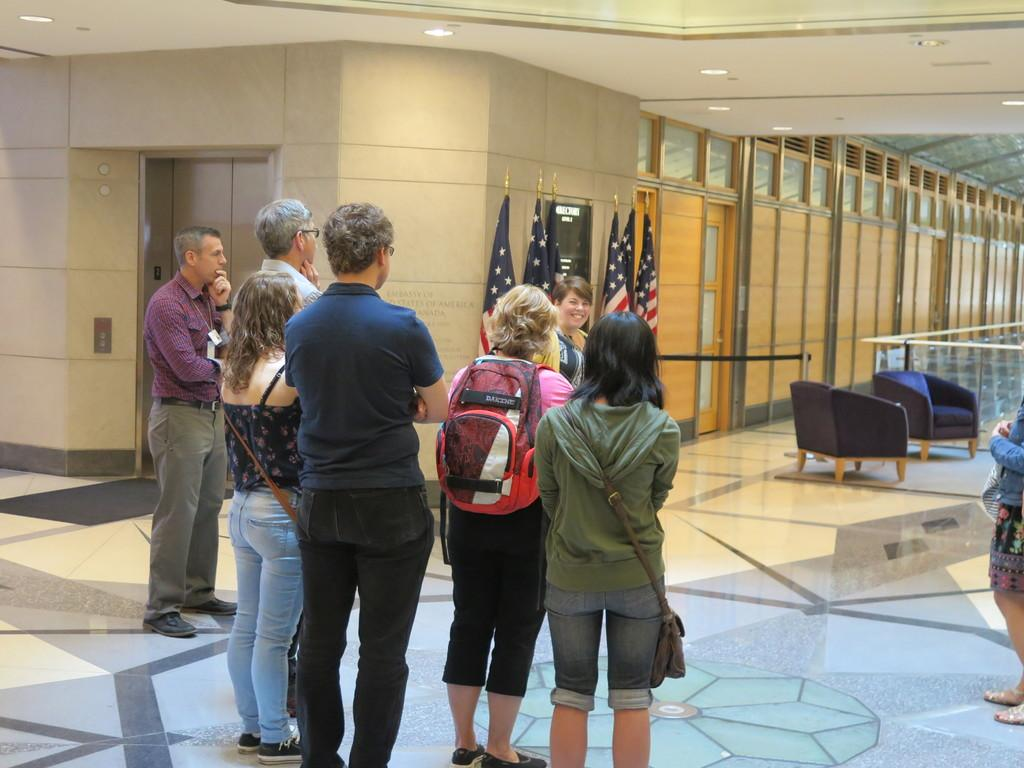How many people are in the image? There are people in the image, but the exact number is not specified. What can be seen in the image besides people? There are flags, a door, a board, and lights attached to the ceiling in the image. What is the person wearing on their back? The person is wearing a bag. What type of structure is depicted in the image? The image depicts an elevator. Can you see a horse swimming in the lake in the image? There is no horse or lake present in the image; it depicts an elevator with people, flags, a door, a board, and lights attached to the ceiling. 